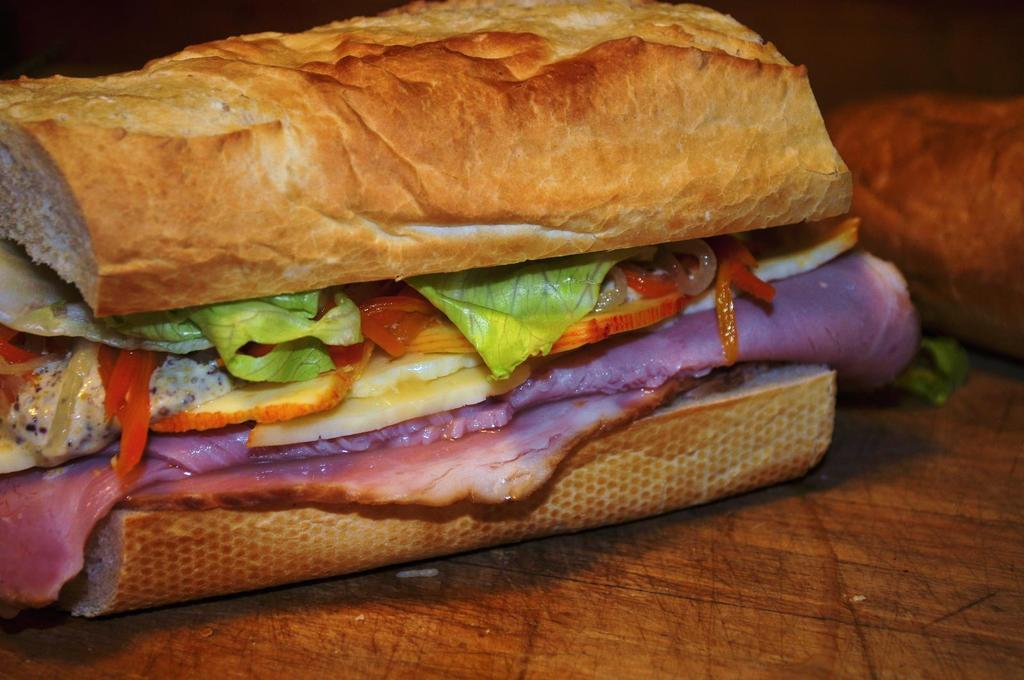What is present on the surface in the image? There is food on a surface in the image. What type of sign is hanging above the food in the image? There is no sign present in the image; it only shows food on a surface. 